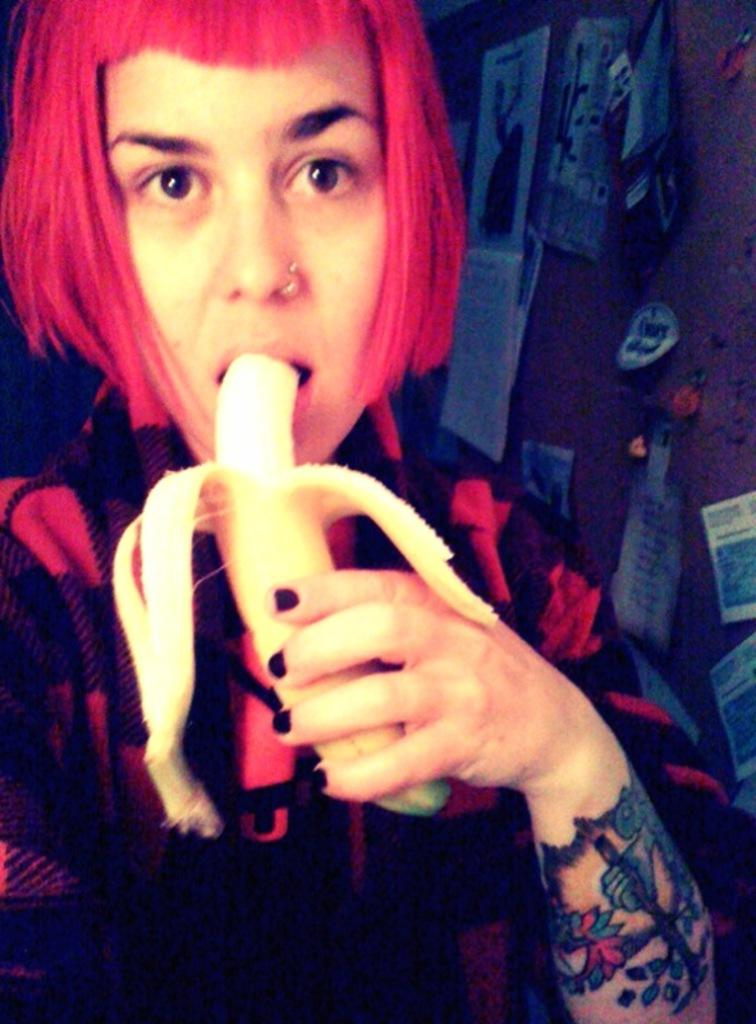Who is the main subject in the foreground of the picture? There is a woman in the foreground of the picture. What is the woman holding in the picture? The woman is holding a banana. What is the woman doing with the banana? The woman has placed the banana in her mouth. What can be seen in the background of the picture? There is a wall in the background of the picture, with papers and posters attached to it. Can you see a giraffe standing next to the woman in the picture? No, there is no giraffe present in the image. How many toes does the woman have on her left foot in the picture? The image does not show the woman's toes, so it is impossible to determine the number of toes on her left foot. 